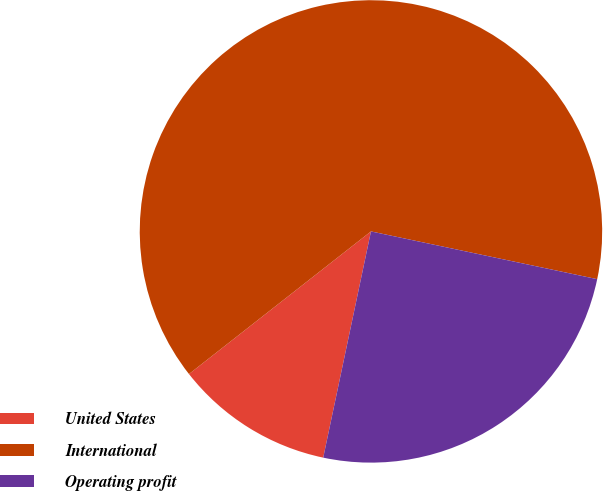<chart> <loc_0><loc_0><loc_500><loc_500><pie_chart><fcel>United States<fcel>International<fcel>Operating profit<nl><fcel>11.11%<fcel>63.89%<fcel>25.0%<nl></chart> 